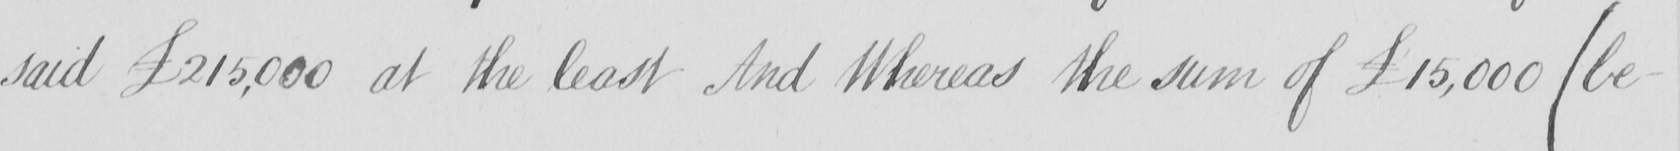What does this handwritten line say? said £215,000 at the least And Whereas the sum of £15,000  ( be- 